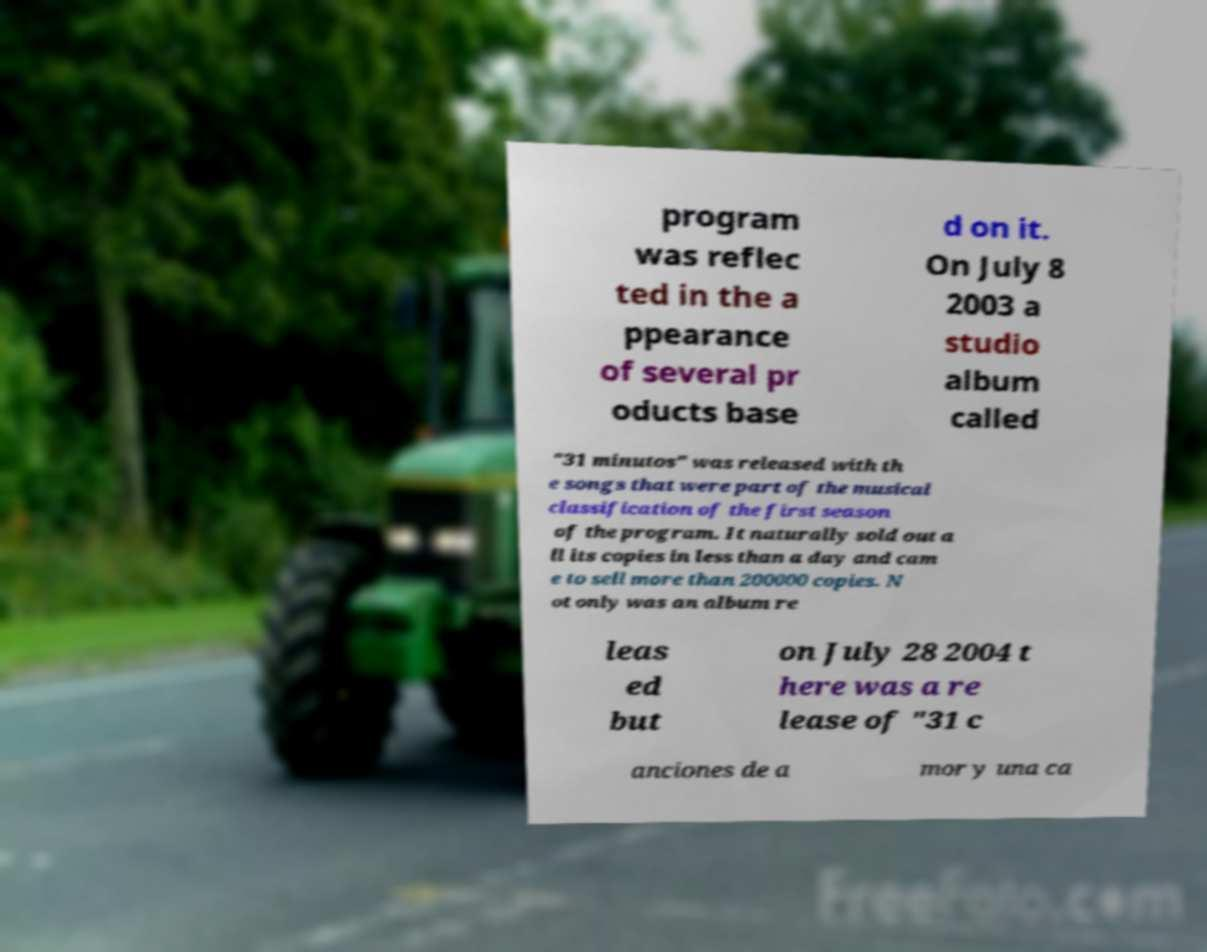What messages or text are displayed in this image? I need them in a readable, typed format. program was reflec ted in the a ppearance of several pr oducts base d on it. On July 8 2003 a studio album called "31 minutos" was released with th e songs that were part of the musical classification of the first season of the program. It naturally sold out a ll its copies in less than a day and cam e to sell more than 200000 copies. N ot only was an album re leas ed but on July 28 2004 t here was a re lease of "31 c anciones de a mor y una ca 